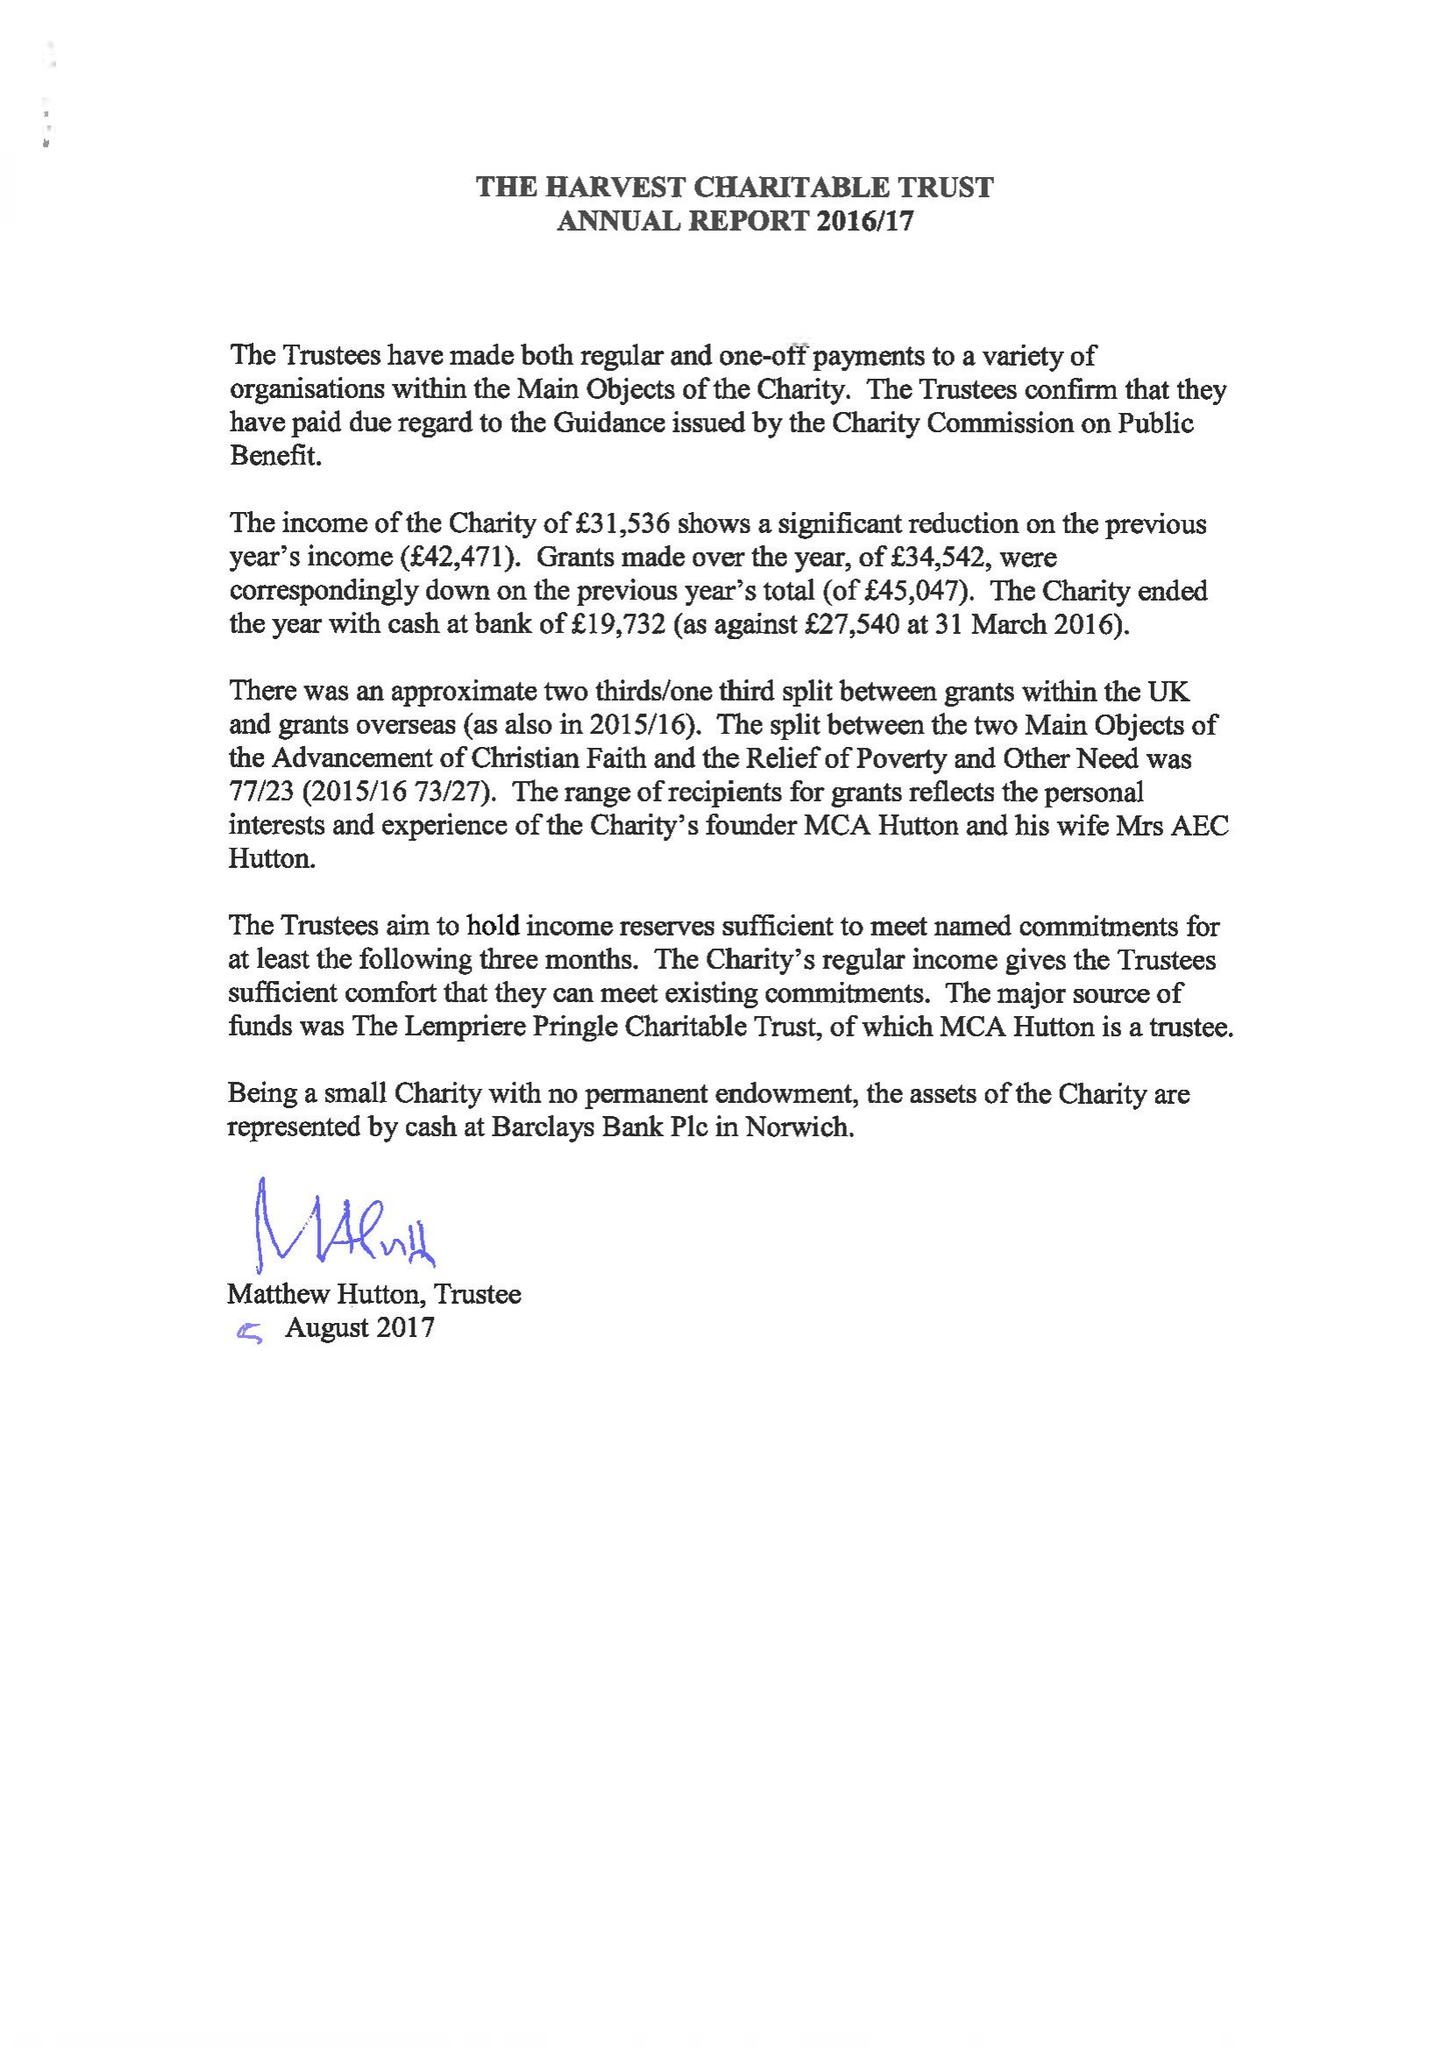What is the value for the address__postcode?
Answer the question using a single word or phrase. NR14 6BQ 